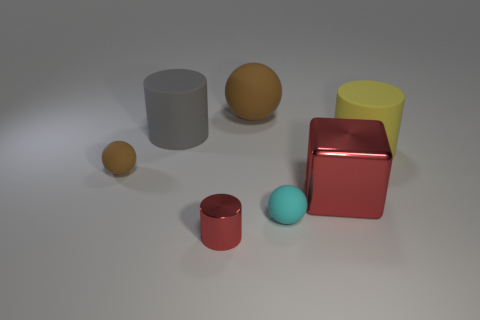How many other things are there of the same material as the red cylinder?
Your answer should be very brief. 1. There is a rubber thing that is in front of the brown rubber ball left of the tiny metal thing; what is its shape?
Give a very brief answer. Sphere. How many objects are either purple balls or spheres that are behind the small brown object?
Ensure brevity in your answer.  1. How many brown things are rubber cubes or cylinders?
Your response must be concise. 0. There is a ball behind the cylinder that is to the right of the small cyan sphere; are there any large blocks to the left of it?
Your response must be concise. No. Is there anything else that is the same size as the cyan matte sphere?
Ensure brevity in your answer.  Yes. Do the large block and the small cylinder have the same color?
Offer a terse response. Yes. There is a shiny block in front of the brown rubber object that is right of the big gray thing; what color is it?
Make the answer very short. Red. What number of tiny things are brown rubber things or blocks?
Your answer should be compact. 1. There is a object that is in front of the yellow cylinder and right of the cyan matte object; what color is it?
Offer a terse response. Red. 